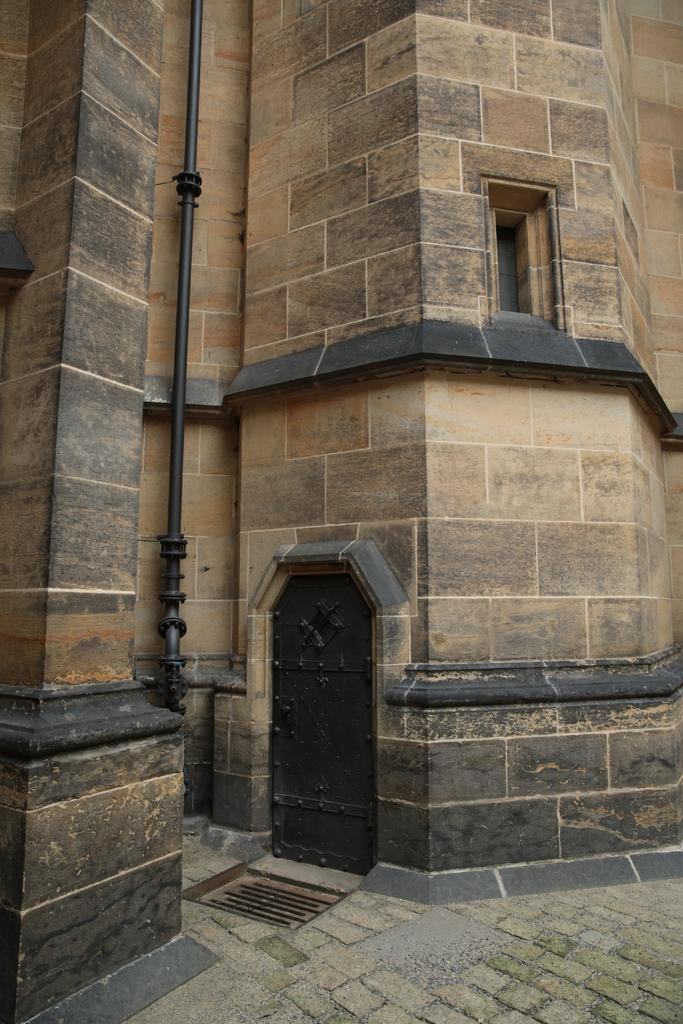What type of structure is in the image? There is a building in the image. What features can be seen on the building? The building has windows and a door. Is there any additional detail on the building? Yes, there is a pipe on the building. What can be seen at the bottom of the image? The ground is visible at the bottom of the image. What type of marble is used for the building's exterior in the image? There is no mention of marble being used for the building's exterior in the image. Can you see any knees in the image? There are no knees visible in the image; it features a building with windows, a door, and a pipe. 